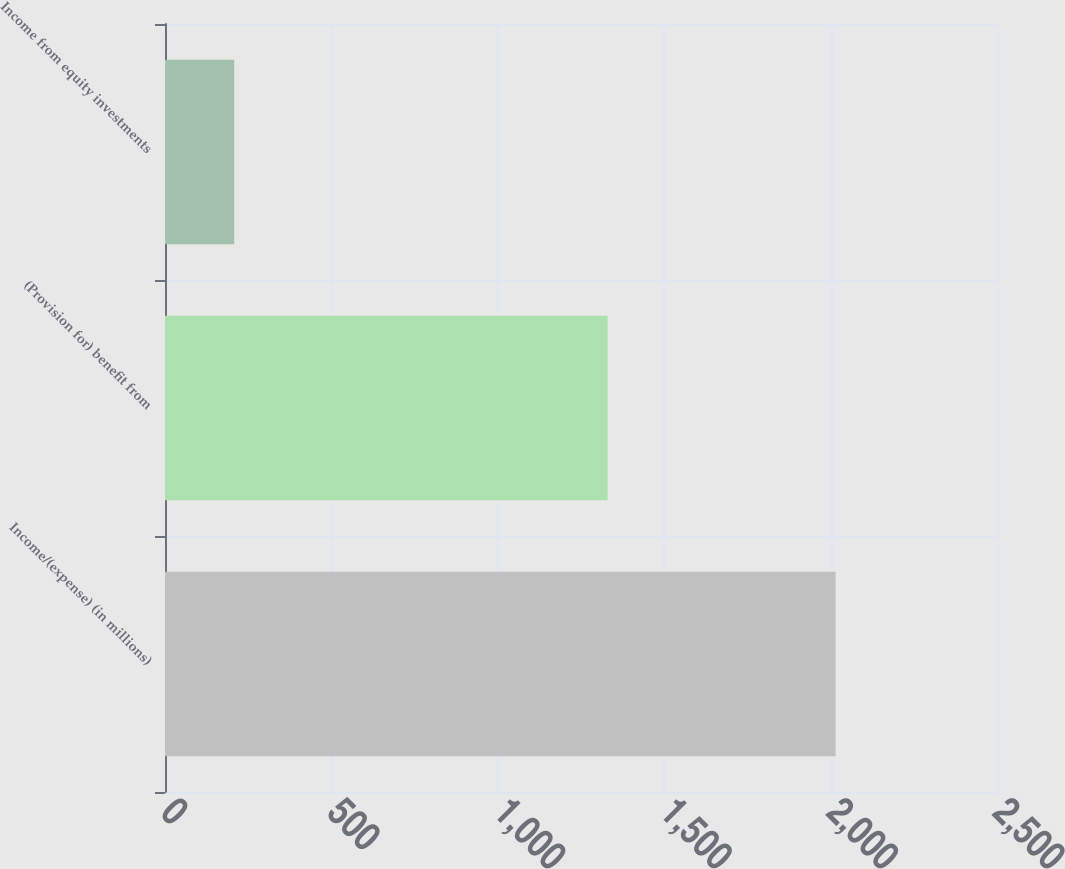Convert chart to OTSL. <chart><loc_0><loc_0><loc_500><loc_500><bar_chart><fcel>Income/(expense) (in millions)<fcel>(Provision for) benefit from<fcel>Income from equity investments<nl><fcel>2015<fcel>1330<fcel>208<nl></chart> 